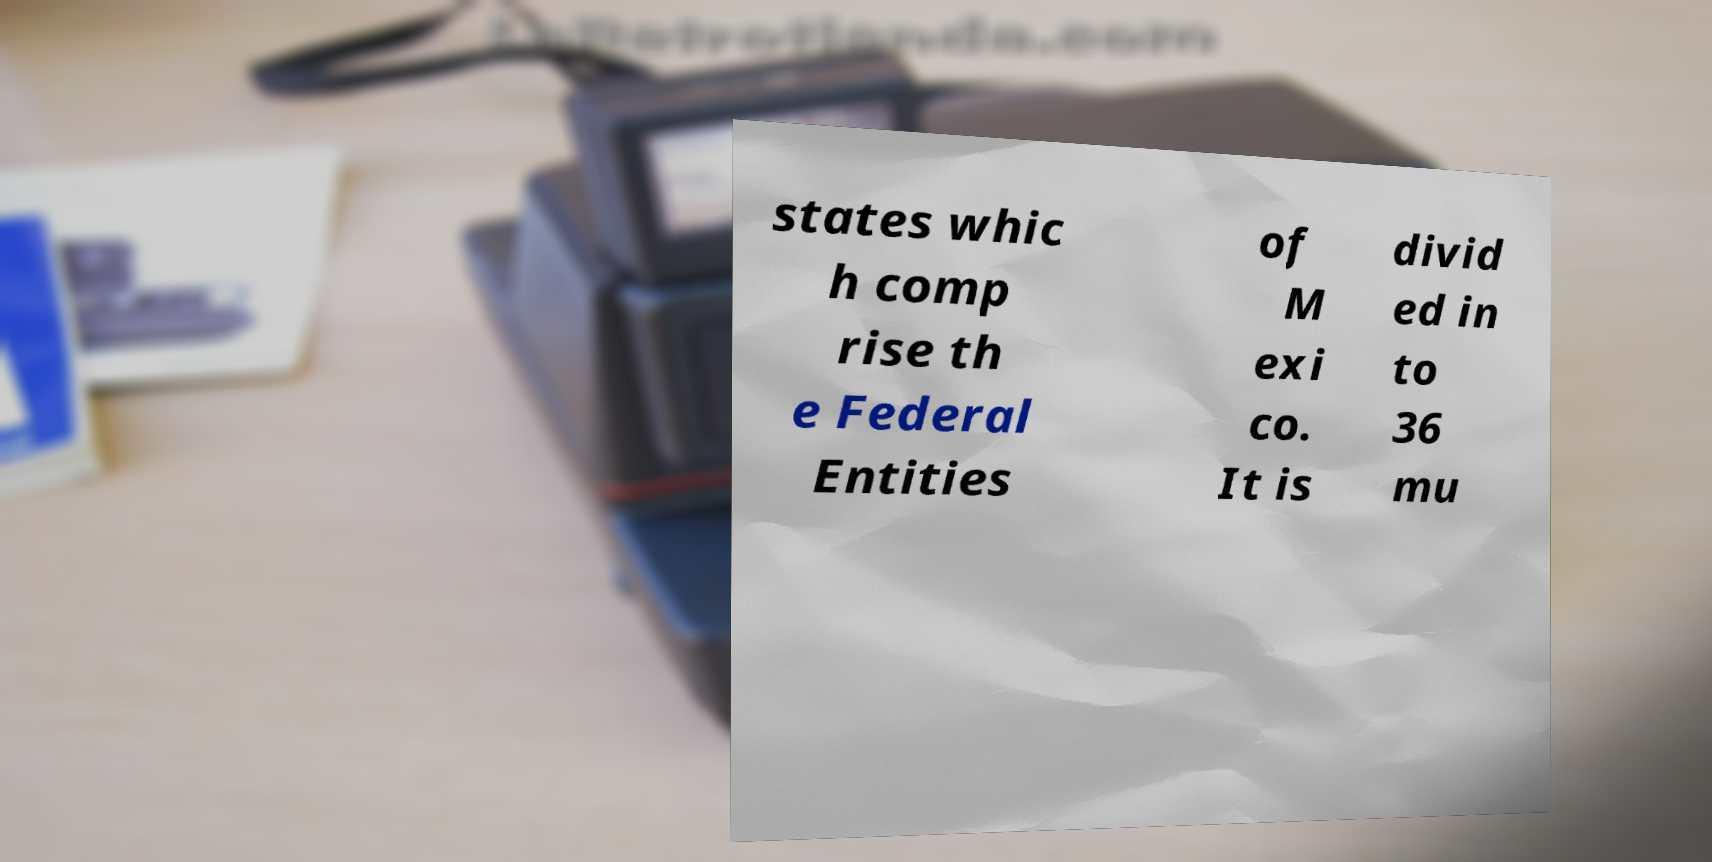Can you read and provide the text displayed in the image?This photo seems to have some interesting text. Can you extract and type it out for me? states whic h comp rise th e Federal Entities of M exi co. It is divid ed in to 36 mu 